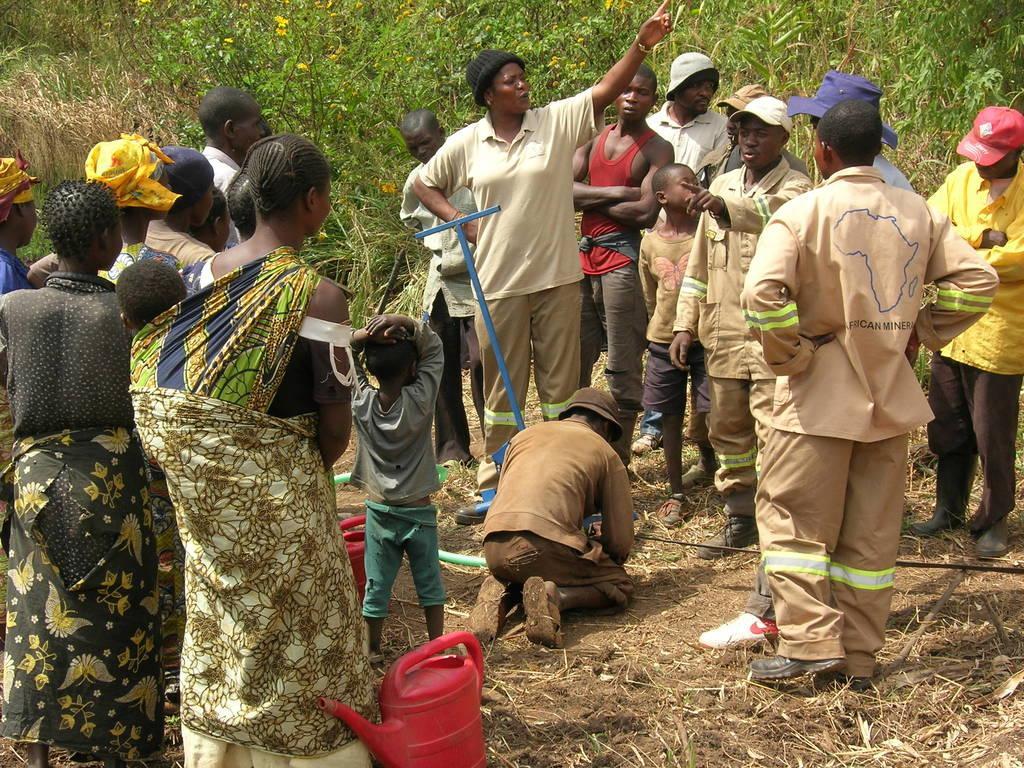Could you give a brief overview of what you see in this image? In the picture we can see a group of people standing and in the middle of them, we can see one man sitting on the knee on the surface of some dried grass and in the background we can see full of plants. 